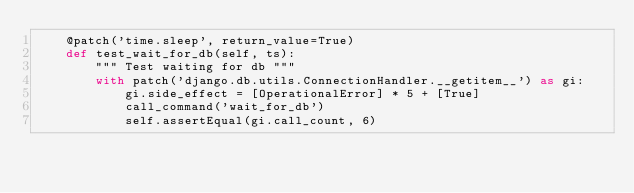Convert code to text. <code><loc_0><loc_0><loc_500><loc_500><_Python_>    @patch('time.sleep', return_value=True)
    def test_wait_for_db(self, ts):
        """ Test waiting for db """
        with patch('django.db.utils.ConnectionHandler.__getitem__') as gi:
            gi.side_effect = [OperationalError] * 5 + [True]
            call_command('wait_for_db')
            self.assertEqual(gi.call_count, 6)
</code> 